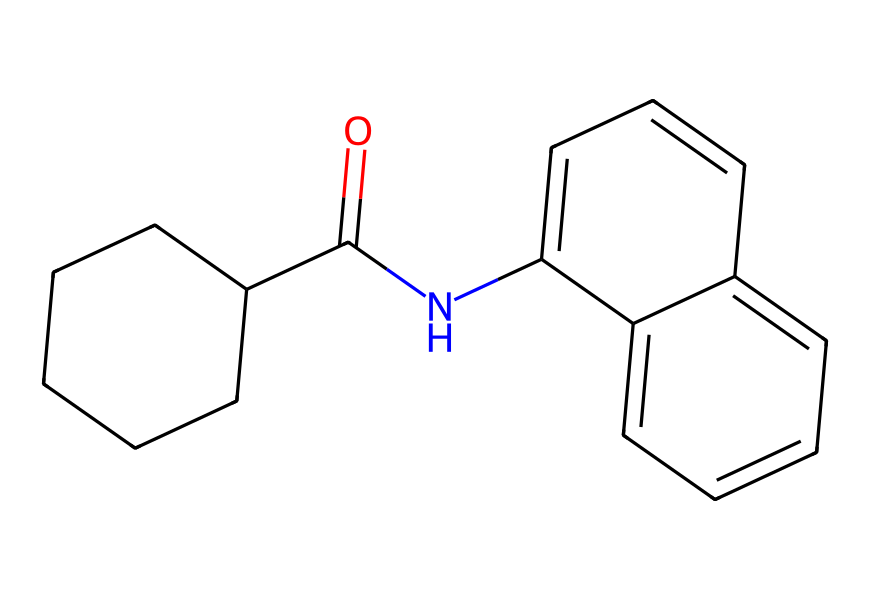What is the molecular formula of the compound represented? To find the molecular formula, count the number of each type of atom present in the SMILES representation. For this structure, there are 19 carbon (C) atoms, 21 hydrogen (H) atoms, 1 nitrogen (N) atom, and 1 oxygen (O) atom. Thus, the molecular formula is C19H21N1O1.
Answer: C19H21N1O1 How many rings are present in the chemical structure? Analyzing the SMILES notation, we can identify the ring structures by observing the connected segments and the numbers indicating where rings close. There are two ring closures indicated, revealing that there are two rings in the structure.
Answer: 2 What is the functional group present in this drug? The presence of the -C(=O)N- linkage in the structure indicates the presence of an amide functional group. This is due to the characteristic carbonyl (C=O) bonded to the nitrogen (N).
Answer: amide Does this compound have any chiral centers? A compound has one or more chiral centers if it has carbon atoms attached to four different groups. By analyzing the structure, it appears that there are no carbon atoms fulfilling this requirement as all carbon atoms are bonded in a way that does not allow for chirality.
Answer: No What type of drug is this likely to be based on its structure? The structure appears to be a polycyclic compound with an amide linkage, which is common in many pharmaceutical drugs, especially those related to anti-cancer or anti-inflammatory agents. Given the complexity and aromatic nature, it is likely an aromatic heterocyclic drug.
Answer: aromatic heterocyclic drug 